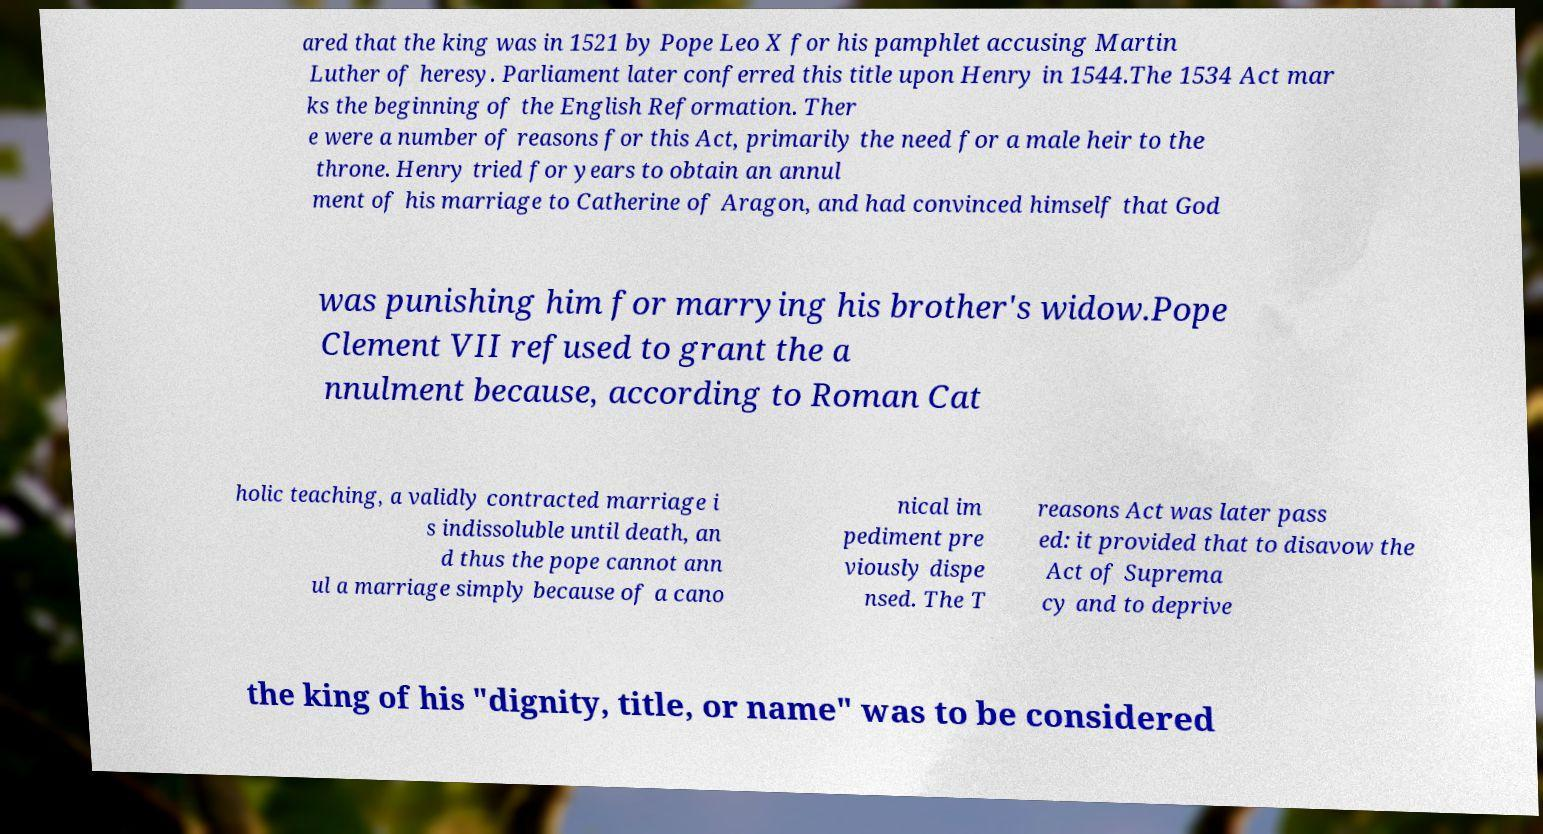Please read and relay the text visible in this image. What does it say? ared that the king was in 1521 by Pope Leo X for his pamphlet accusing Martin Luther of heresy. Parliament later conferred this title upon Henry in 1544.The 1534 Act mar ks the beginning of the English Reformation. Ther e were a number of reasons for this Act, primarily the need for a male heir to the throne. Henry tried for years to obtain an annul ment of his marriage to Catherine of Aragon, and had convinced himself that God was punishing him for marrying his brother's widow.Pope Clement VII refused to grant the a nnulment because, according to Roman Cat holic teaching, a validly contracted marriage i s indissoluble until death, an d thus the pope cannot ann ul a marriage simply because of a cano nical im pediment pre viously dispe nsed. The T reasons Act was later pass ed: it provided that to disavow the Act of Suprema cy and to deprive the king of his "dignity, title, or name" was to be considered 